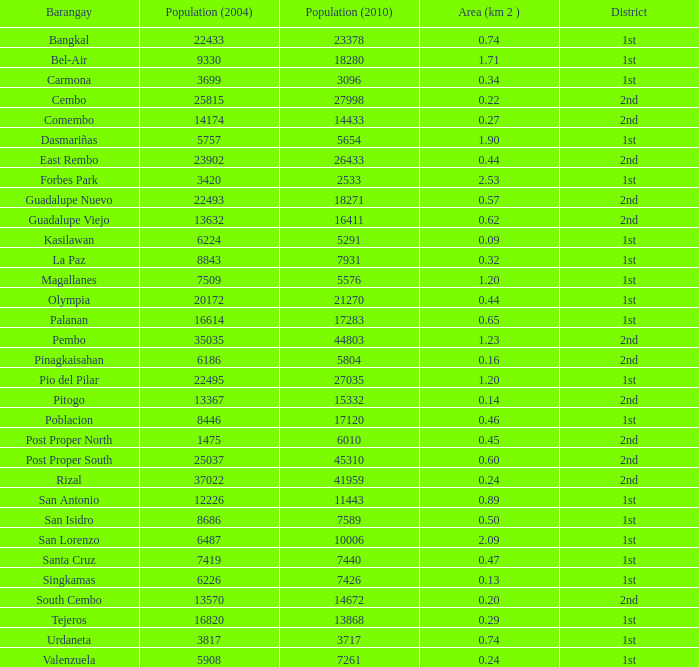What is the area where barangay is guadalupe viejo? 0.62. 